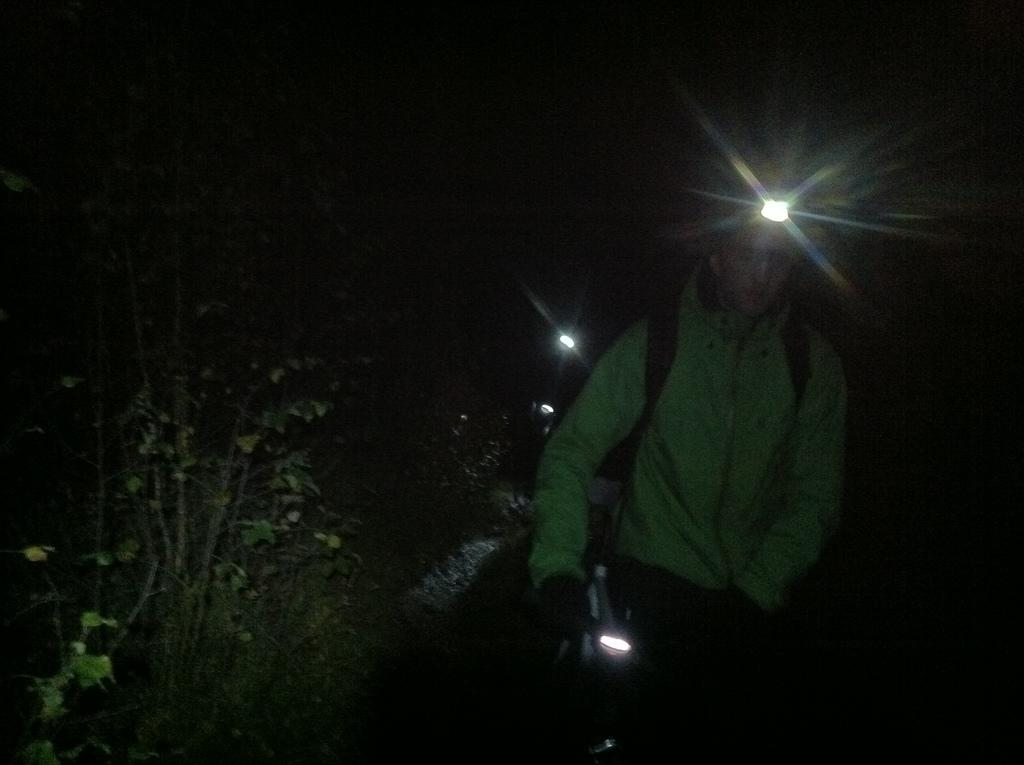What are the persons in the image doing? The persons in the image are walking. What are the persons holding while walking? The persons are holding lights. What can be seen on the left side of the image? There are trees on the left side of the image. What type of copper object can be seen in the image? There is no copper object present in the image. What type of quartz formation is visible in the image? There is no quartz formation present in the image. 